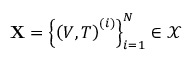Convert formula to latex. <formula><loc_0><loc_0><loc_500><loc_500>X = \left \{ \left ( V , T \right ) ^ { ( i ) } \right \} _ { i = 1 } ^ { N } \in \mathcal { X }</formula> 